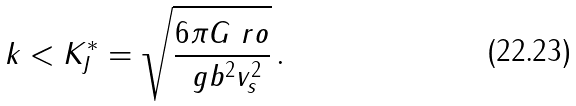<formula> <loc_0><loc_0><loc_500><loc_500>k < K _ { J } ^ { * } = \sqrt { \frac { 6 \pi G \ r o } { \ g b ^ { 2 } v _ { s } ^ { 2 } } } \, .</formula> 